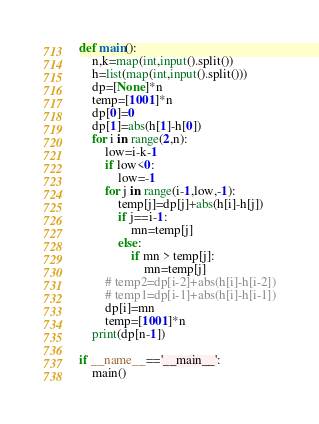<code> <loc_0><loc_0><loc_500><loc_500><_Python_>
def main():
    n,k=map(int,input().split())
    h=list(map(int,input().split()))
    dp=[None]*n
    temp=[1001]*n
    dp[0]=0
    dp[1]=abs(h[1]-h[0])
    for i in range(2,n):
        low=i-k-1
        if low<0:
            low=-1
        for j in range(i-1,low,-1):
            temp[j]=dp[j]+abs(h[i]-h[j])
            if j==i-1:
                mn=temp[j]
            else:
                if mn > temp[j]:
                    mn=temp[j]
        # temp2=dp[i-2]+abs(h[i]-h[i-2])
        # temp1=dp[i-1]+abs(h[i]-h[i-1])
        dp[i]=mn
        temp=[1001]*n
    print(dp[n-1])

if __name__=='__main__':
    main()
</code> 